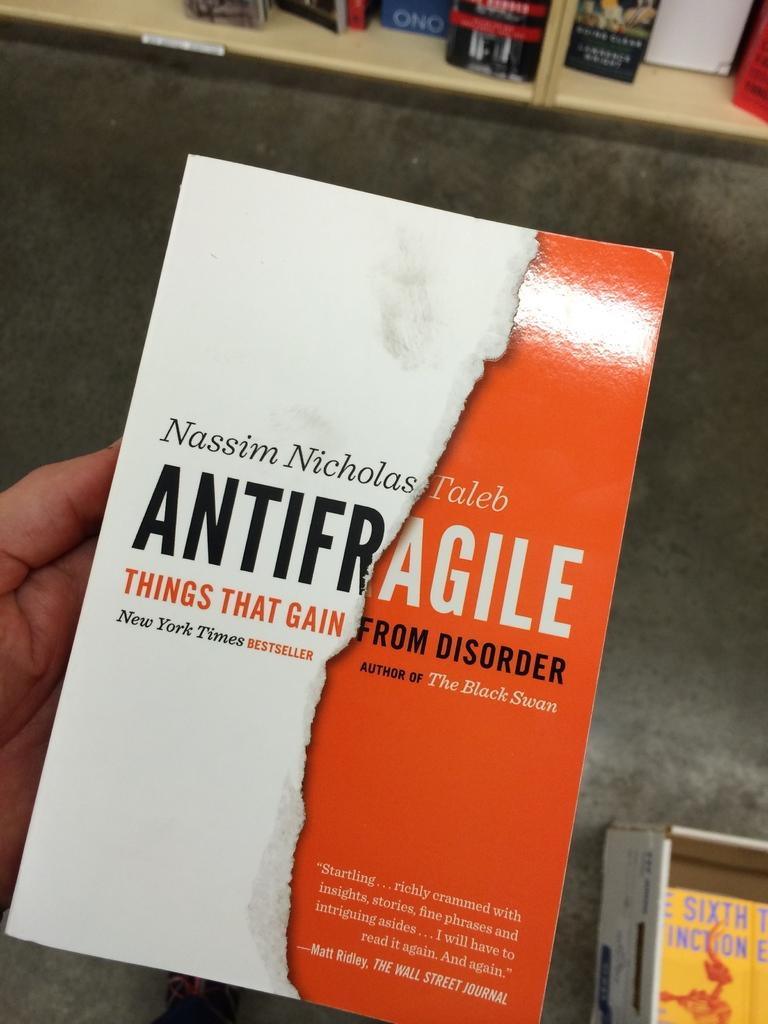Provide a one-sentence caption for the provided image. A person is holding a book by Nassim Nicholas Taleb called "Antifragile". 